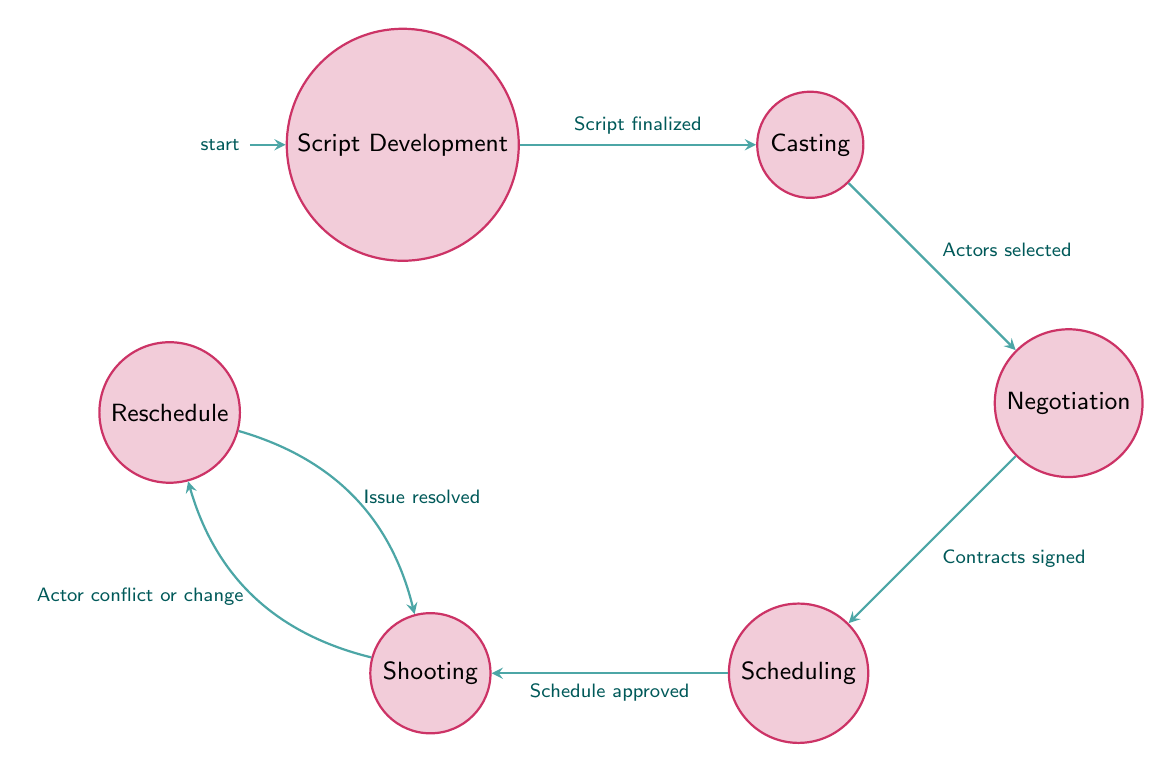What is the first state in this diagram? The diagram starts with the initial state labeled "Script Development," which is the first state in the flow of managing actor availability and scheduling.
Answer: Script Development How many states are in the diagram? There are six distinct states represented in the flow: Script Development, Casting, Negotiation, Scheduling, Shooting, and Reschedule. Counting each of these gives a total of six.
Answer: 6 What is the transition condition from "Casting" to "Negotiation"? The transition from "Casting" to "Negotiation" occurs when the condition "Actors selected" is met, indicating that casting has successfully identified the actors needed.
Answer: Actors selected In which state do you move to after "Scheduling"? After the state "Scheduling," the diagram indicates a transition to the state "Shooting" upon approval of the schedule, meaning the filming process begins afterward.
Answer: Shooting What leads to the "Reschedule" state? The "Reschedule" state is reached from the "Shooting" state when there is an "Actor conflict or change," which necessitates adjustments in the schedule.
Answer: Actor conflict or change How do you get back to "Shooting" from "Reschedule"? To return to "Shooting" from "Reschedule," the condition "Issue resolved" must be satisfied, indicating that the concerns regarding actor availability have been addressed.
Answer: Issue resolved What is the condition that allows moving to "Scheduling"? The transition to "Scheduling" occurs when the condition "Contracts signed" is satisfied, confirming that the actor agreements are finalized and available for scheduling.
Answer: Contracts signed What is the relationship between "Shooting" and "Reschedule"? The relationship is a feedback loop where "Shooting" can send transitions to "Reschedule" if conflicts arise, and can return to "Shooting" after those issues are resolved.
Answer: Feedback loop 